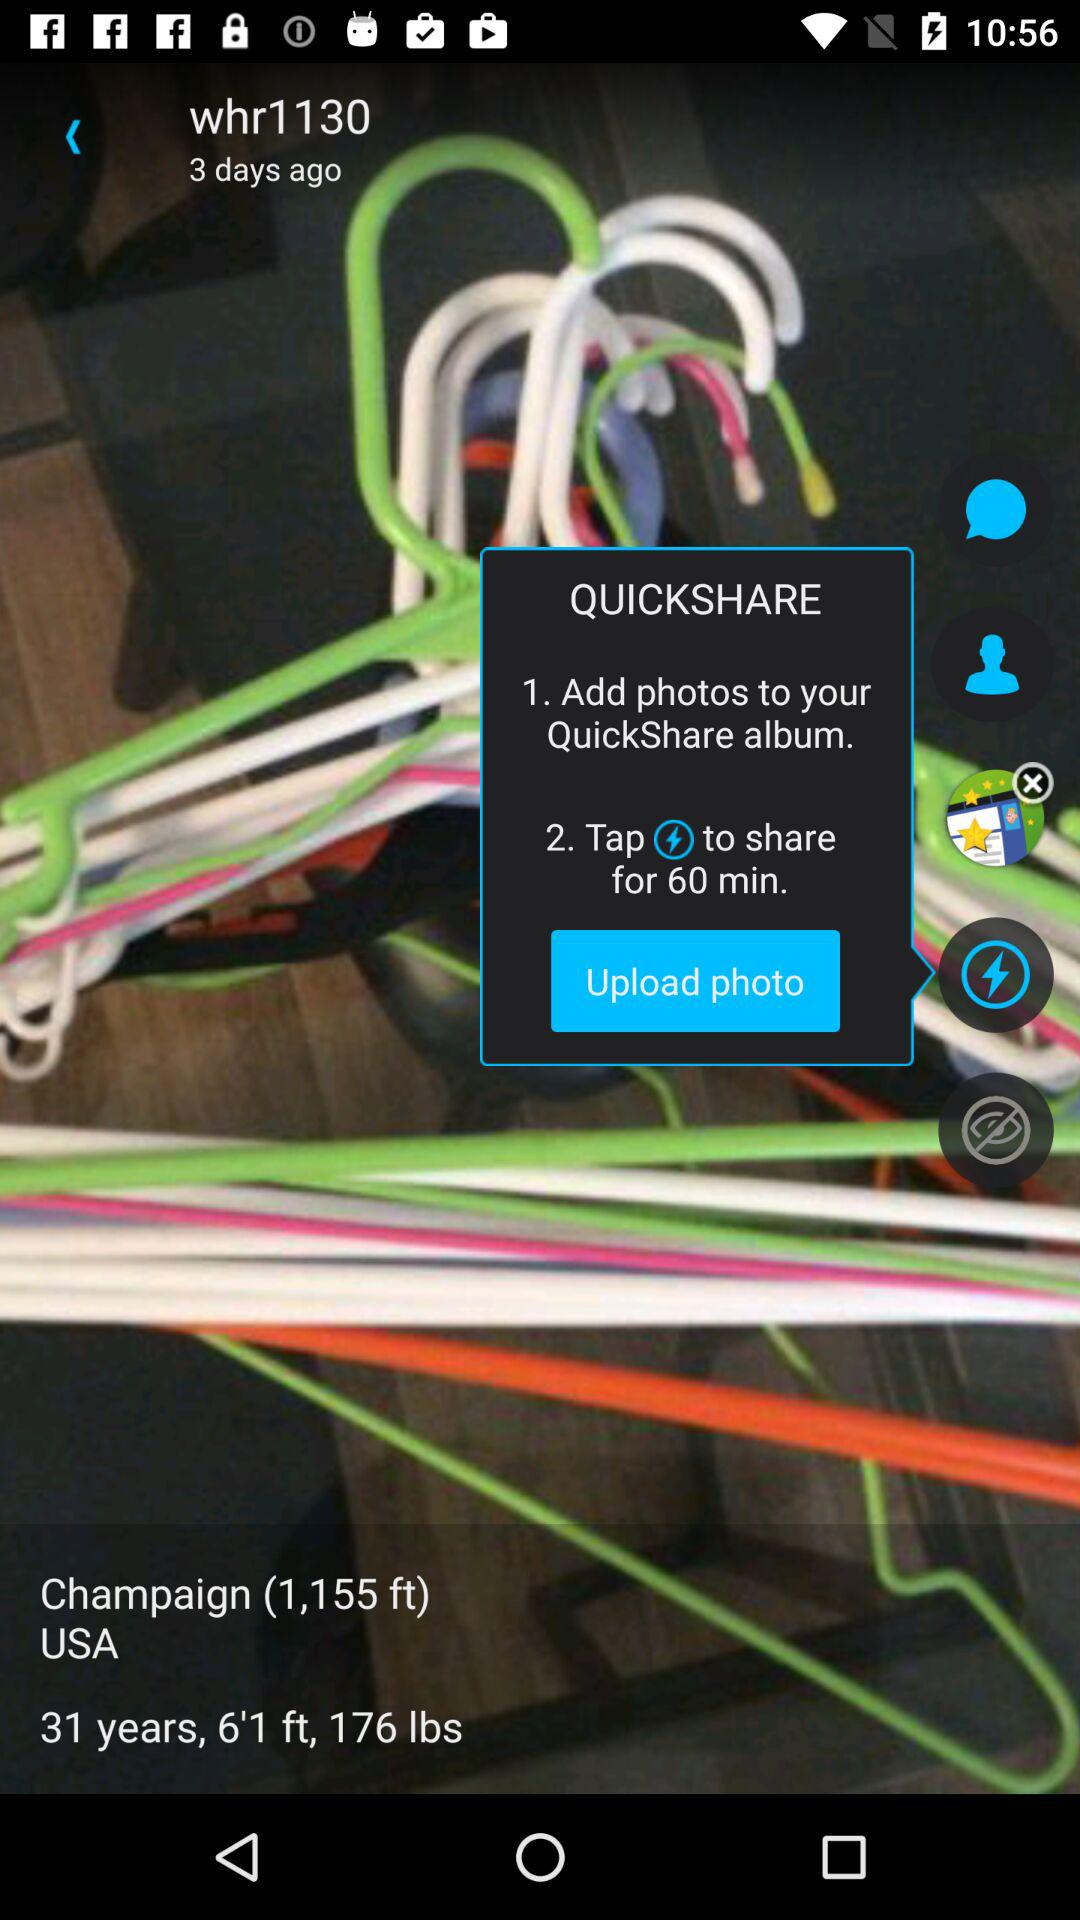What is the weight? The weight is 176 lbs. 